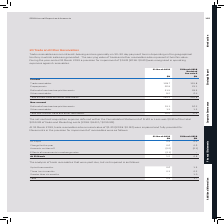According to Sophos Group's financial document, What represents the fair value of trade and other receivables? The carrying value of trade and other receivables. The document states: "graphical territory in which sales are generated. The carrying value of trade and other receivables also represents their fair value. During the year-..." Also, What was recognised in operating expenses against receivables in 2019? a provision for impairment of $0.6M (2018: $0.6M). The document states: "ir fair value. During the year-ended 31 March 2019 a provision for impairment of $0.6M (2018: $0.6M) was recognised in operating expenses against rece..." Also, What are the components comprising the total non-current trade and other receivables? The document shows two values: Deferral of contract acquisition costs and Other receivables. From the document: "Other receivables 8.2 6.4 Deferral of contract acquisition costs 31.5 29.5..." Additionally, In which year was the amount of Prepayments larger? According to the financial document, 2019. The relevant text states: "their fair value. During the year-ended 31 March 2019 a provision for impairment of $0.6M (2018: $0.6M) was recognised in operating expenses against rece..." Also, can you calculate: What was the change in trade receivables in 2019 from 2018? Based on the calculation: 128.7-151.8, the result is -23.1 (in millions). This is based on the information: "Trade receivables 128.7 151.8 Trade receivables 128.7 151.8..." The key data points involved are: 128.7, 151.8. Also, can you calculate: What was the percentage change in trade receivables in 2019 from 2018? To answer this question, I need to perform calculations using the financial data. The calculation is: (128.7-151.8)/151.8, which equals -15.22 (percentage). This is based on the information: "Trade receivables 128.7 151.8 Trade receivables 128.7 151.8..." The key data points involved are: 128.7, 151.8. 